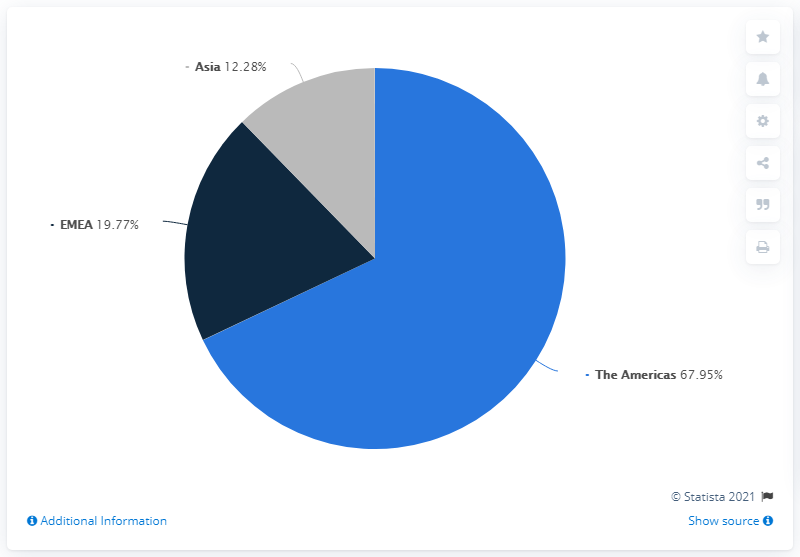Draw attention to some important aspects in this diagram. The sum of Asia and EMEA is 32.05. The Americas region is the predominant region in the pie chart. 